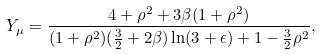Convert formula to latex. <formula><loc_0><loc_0><loc_500><loc_500>Y _ { \mu } = \frac { 4 + \rho ^ { 2 } + 3 \beta ( 1 + \rho ^ { 2 } ) } { ( 1 + \rho ^ { 2 } ) ( \frac { 3 } { 2 } + 2 \beta ) \ln ( 3 + \epsilon ) + 1 - \frac { 3 } { 2 } \rho ^ { 2 } } ,</formula> 